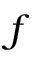<formula> <loc_0><loc_0><loc_500><loc_500>f</formula> 